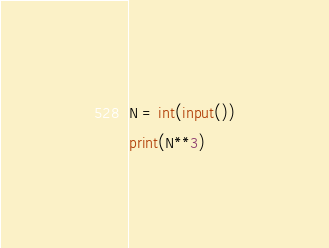<code> <loc_0><loc_0><loc_500><loc_500><_Python_>N = int(input())
print(N**3)</code> 